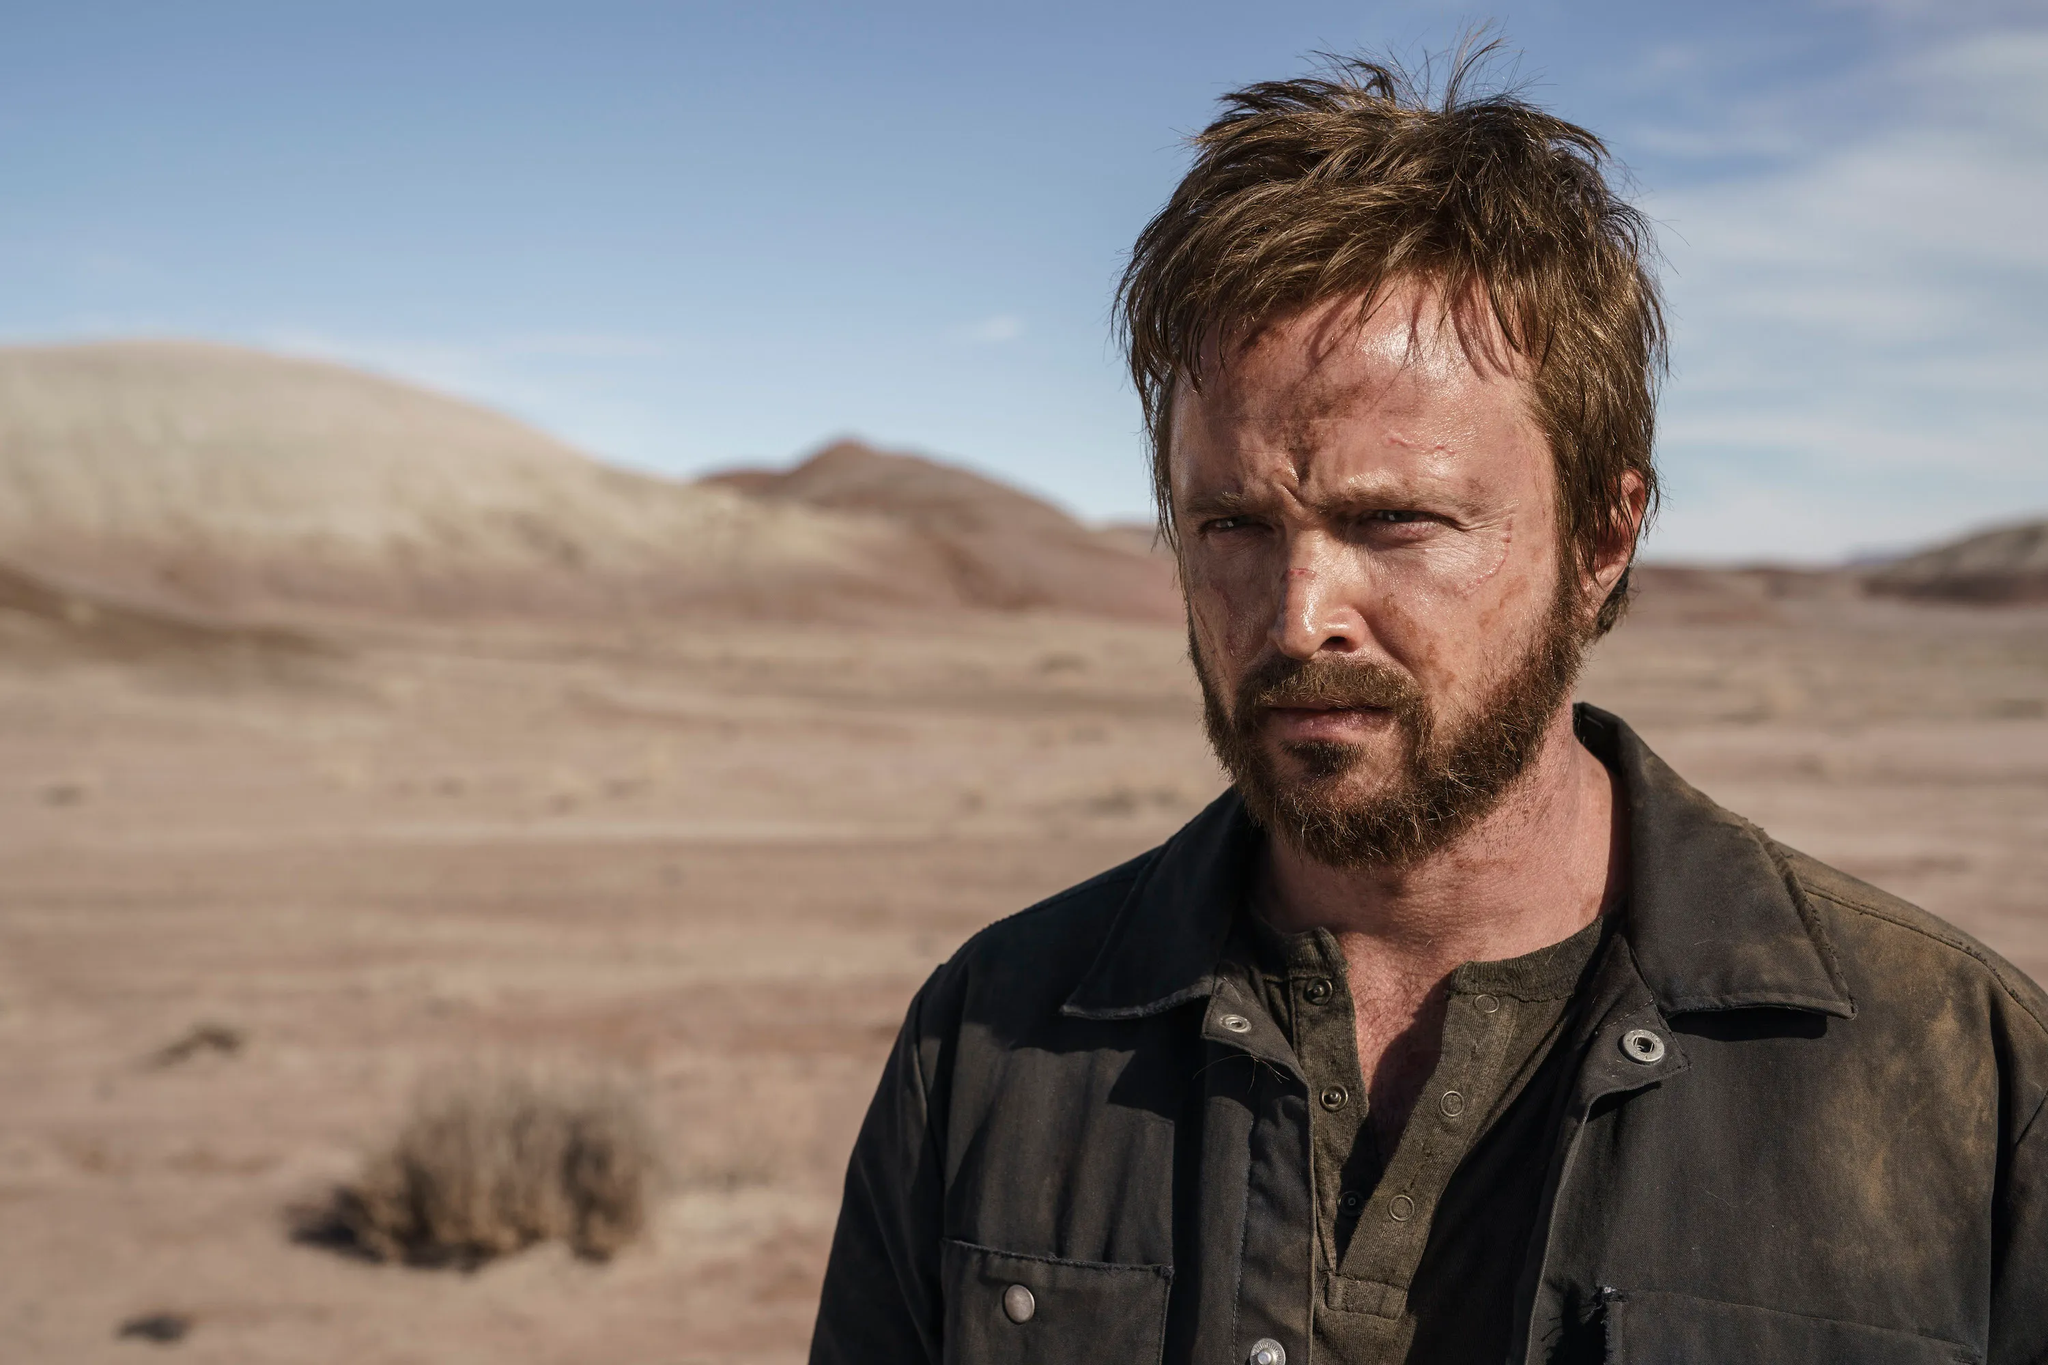What might be going through his mind as he stands there? It's possible that he is reflecting on a significant event or decision. The solemn expression and isolated setting might suggest he is contemplating a challenging personal or professional situation. The vast emptiness around him emphasizes his solitude, perhaps indicating a moment of self-reflection or a pivotal turning point in his story. 